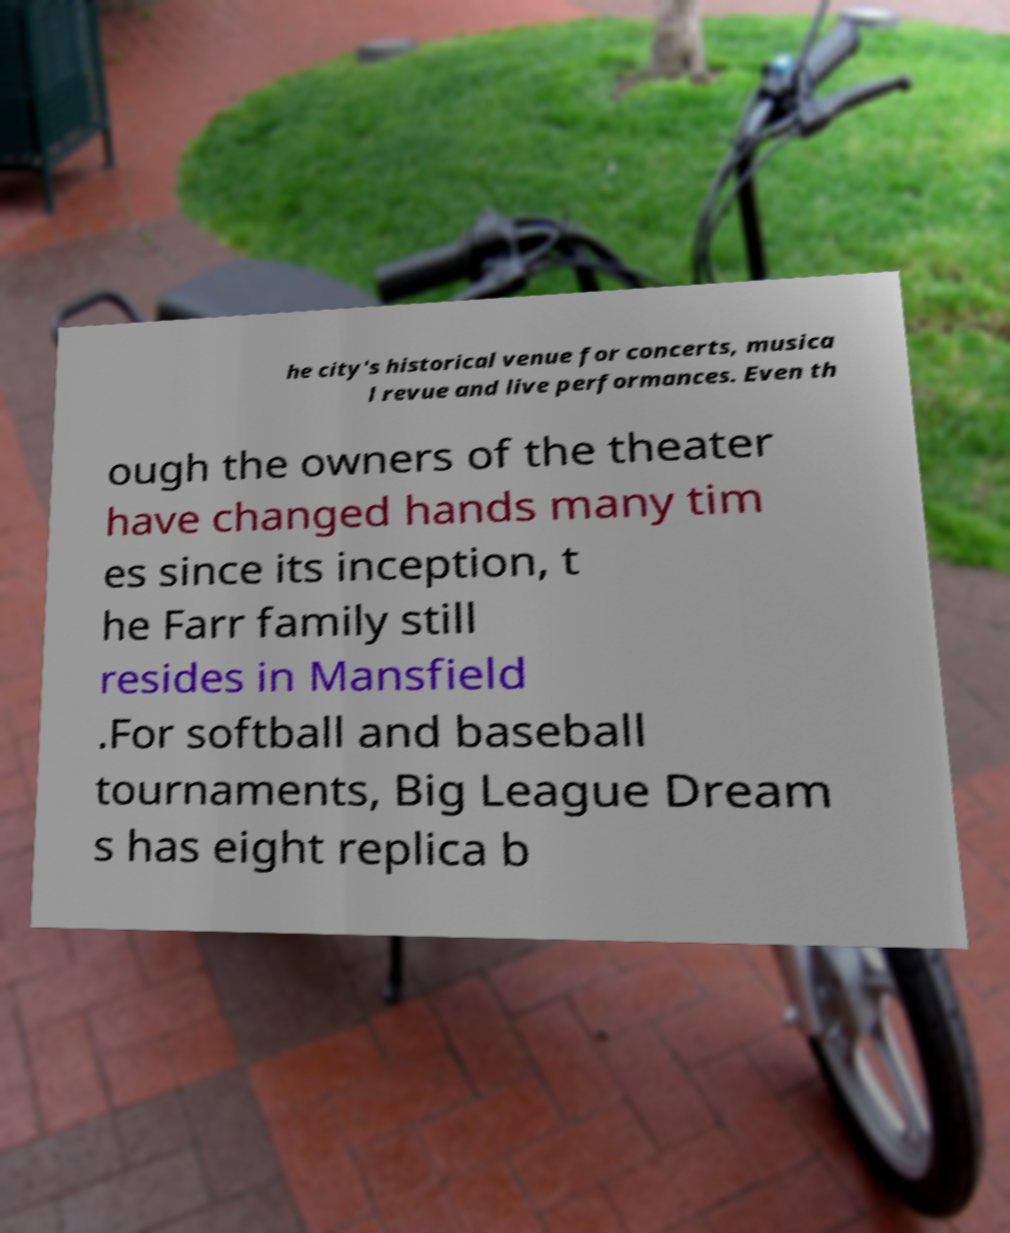Please read and relay the text visible in this image. What does it say? he city's historical venue for concerts, musica l revue and live performances. Even th ough the owners of the theater have changed hands many tim es since its inception, t he Farr family still resides in Mansfield .For softball and baseball tournaments, Big League Dream s has eight replica b 